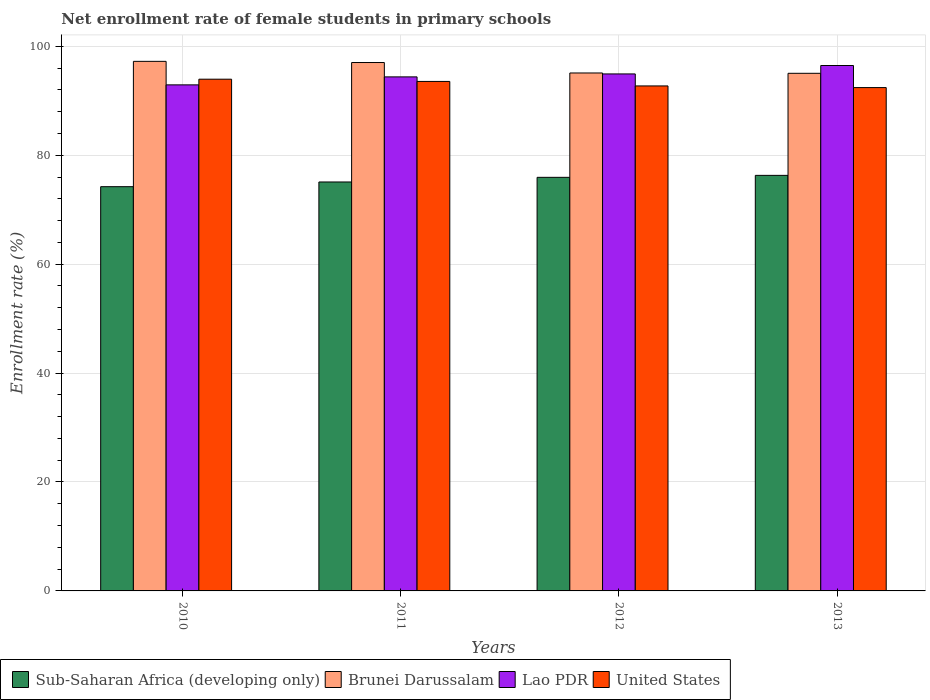What is the label of the 4th group of bars from the left?
Your response must be concise. 2013. In how many cases, is the number of bars for a given year not equal to the number of legend labels?
Keep it short and to the point. 0. What is the net enrollment rate of female students in primary schools in United States in 2011?
Provide a succinct answer. 93.55. Across all years, what is the maximum net enrollment rate of female students in primary schools in United States?
Your answer should be compact. 93.96. Across all years, what is the minimum net enrollment rate of female students in primary schools in Brunei Darussalam?
Provide a succinct answer. 95.04. In which year was the net enrollment rate of female students in primary schools in United States maximum?
Offer a very short reply. 2010. In which year was the net enrollment rate of female students in primary schools in United States minimum?
Offer a terse response. 2013. What is the total net enrollment rate of female students in primary schools in Brunei Darussalam in the graph?
Your answer should be compact. 384.4. What is the difference between the net enrollment rate of female students in primary schools in Lao PDR in 2011 and that in 2012?
Make the answer very short. -0.54. What is the difference between the net enrollment rate of female students in primary schools in Lao PDR in 2010 and the net enrollment rate of female students in primary schools in Brunei Darussalam in 2013?
Your answer should be compact. -2.12. What is the average net enrollment rate of female students in primary schools in Lao PDR per year?
Your answer should be very brief. 94.68. In the year 2012, what is the difference between the net enrollment rate of female students in primary schools in Sub-Saharan Africa (developing only) and net enrollment rate of female students in primary schools in United States?
Your answer should be compact. -16.78. What is the ratio of the net enrollment rate of female students in primary schools in United States in 2010 to that in 2013?
Your response must be concise. 1.02. What is the difference between the highest and the second highest net enrollment rate of female students in primary schools in Brunei Darussalam?
Ensure brevity in your answer.  0.21. What is the difference between the highest and the lowest net enrollment rate of female students in primary schools in Lao PDR?
Offer a very short reply. 3.55. Is the sum of the net enrollment rate of female students in primary schools in Brunei Darussalam in 2012 and 2013 greater than the maximum net enrollment rate of female students in primary schools in Sub-Saharan Africa (developing only) across all years?
Make the answer very short. Yes. Is it the case that in every year, the sum of the net enrollment rate of female students in primary schools in Brunei Darussalam and net enrollment rate of female students in primary schools in Lao PDR is greater than the sum of net enrollment rate of female students in primary schools in Sub-Saharan Africa (developing only) and net enrollment rate of female students in primary schools in United States?
Provide a succinct answer. Yes. What does the 2nd bar from the left in 2012 represents?
Offer a terse response. Brunei Darussalam. What does the 2nd bar from the right in 2013 represents?
Your response must be concise. Lao PDR. Does the graph contain grids?
Your response must be concise. Yes. How many legend labels are there?
Your response must be concise. 4. How are the legend labels stacked?
Provide a succinct answer. Horizontal. What is the title of the graph?
Provide a succinct answer. Net enrollment rate of female students in primary schools. What is the label or title of the X-axis?
Make the answer very short. Years. What is the label or title of the Y-axis?
Keep it short and to the point. Enrollment rate (%). What is the Enrollment rate (%) in Sub-Saharan Africa (developing only) in 2010?
Make the answer very short. 74.22. What is the Enrollment rate (%) of Brunei Darussalam in 2010?
Your answer should be very brief. 97.24. What is the Enrollment rate (%) in Lao PDR in 2010?
Your response must be concise. 92.92. What is the Enrollment rate (%) of United States in 2010?
Your response must be concise. 93.96. What is the Enrollment rate (%) in Sub-Saharan Africa (developing only) in 2011?
Provide a succinct answer. 75.09. What is the Enrollment rate (%) in Brunei Darussalam in 2011?
Your answer should be compact. 97.02. What is the Enrollment rate (%) of Lao PDR in 2011?
Ensure brevity in your answer.  94.38. What is the Enrollment rate (%) in United States in 2011?
Provide a succinct answer. 93.55. What is the Enrollment rate (%) of Sub-Saharan Africa (developing only) in 2012?
Give a very brief answer. 75.94. What is the Enrollment rate (%) in Brunei Darussalam in 2012?
Offer a terse response. 95.1. What is the Enrollment rate (%) of Lao PDR in 2012?
Your response must be concise. 94.93. What is the Enrollment rate (%) in United States in 2012?
Keep it short and to the point. 92.72. What is the Enrollment rate (%) of Sub-Saharan Africa (developing only) in 2013?
Provide a short and direct response. 76.3. What is the Enrollment rate (%) of Brunei Darussalam in 2013?
Your answer should be very brief. 95.04. What is the Enrollment rate (%) in Lao PDR in 2013?
Offer a very short reply. 96.47. What is the Enrollment rate (%) in United States in 2013?
Give a very brief answer. 92.42. Across all years, what is the maximum Enrollment rate (%) of Sub-Saharan Africa (developing only)?
Offer a terse response. 76.3. Across all years, what is the maximum Enrollment rate (%) of Brunei Darussalam?
Keep it short and to the point. 97.24. Across all years, what is the maximum Enrollment rate (%) in Lao PDR?
Ensure brevity in your answer.  96.47. Across all years, what is the maximum Enrollment rate (%) of United States?
Make the answer very short. 93.96. Across all years, what is the minimum Enrollment rate (%) in Sub-Saharan Africa (developing only)?
Keep it short and to the point. 74.22. Across all years, what is the minimum Enrollment rate (%) in Brunei Darussalam?
Your response must be concise. 95.04. Across all years, what is the minimum Enrollment rate (%) in Lao PDR?
Your answer should be compact. 92.92. Across all years, what is the minimum Enrollment rate (%) in United States?
Make the answer very short. 92.42. What is the total Enrollment rate (%) in Sub-Saharan Africa (developing only) in the graph?
Provide a succinct answer. 301.55. What is the total Enrollment rate (%) in Brunei Darussalam in the graph?
Provide a succinct answer. 384.4. What is the total Enrollment rate (%) of Lao PDR in the graph?
Make the answer very short. 378.7. What is the total Enrollment rate (%) of United States in the graph?
Give a very brief answer. 372.65. What is the difference between the Enrollment rate (%) in Sub-Saharan Africa (developing only) in 2010 and that in 2011?
Make the answer very short. -0.86. What is the difference between the Enrollment rate (%) in Brunei Darussalam in 2010 and that in 2011?
Provide a short and direct response. 0.21. What is the difference between the Enrollment rate (%) in Lao PDR in 2010 and that in 2011?
Keep it short and to the point. -1.46. What is the difference between the Enrollment rate (%) in United States in 2010 and that in 2011?
Make the answer very short. 0.41. What is the difference between the Enrollment rate (%) of Sub-Saharan Africa (developing only) in 2010 and that in 2012?
Your answer should be very brief. -1.71. What is the difference between the Enrollment rate (%) of Brunei Darussalam in 2010 and that in 2012?
Provide a short and direct response. 2.13. What is the difference between the Enrollment rate (%) in Lao PDR in 2010 and that in 2012?
Your answer should be compact. -2.01. What is the difference between the Enrollment rate (%) in United States in 2010 and that in 2012?
Ensure brevity in your answer.  1.24. What is the difference between the Enrollment rate (%) in Sub-Saharan Africa (developing only) in 2010 and that in 2013?
Your answer should be very brief. -2.08. What is the difference between the Enrollment rate (%) of Brunei Darussalam in 2010 and that in 2013?
Offer a terse response. 2.19. What is the difference between the Enrollment rate (%) in Lao PDR in 2010 and that in 2013?
Offer a very short reply. -3.55. What is the difference between the Enrollment rate (%) in United States in 2010 and that in 2013?
Offer a very short reply. 1.54. What is the difference between the Enrollment rate (%) in Sub-Saharan Africa (developing only) in 2011 and that in 2012?
Your answer should be very brief. -0.85. What is the difference between the Enrollment rate (%) of Brunei Darussalam in 2011 and that in 2012?
Your response must be concise. 1.92. What is the difference between the Enrollment rate (%) in Lao PDR in 2011 and that in 2012?
Your response must be concise. -0.54. What is the difference between the Enrollment rate (%) of United States in 2011 and that in 2012?
Keep it short and to the point. 0.83. What is the difference between the Enrollment rate (%) in Sub-Saharan Africa (developing only) in 2011 and that in 2013?
Provide a short and direct response. -1.21. What is the difference between the Enrollment rate (%) of Brunei Darussalam in 2011 and that in 2013?
Offer a terse response. 1.98. What is the difference between the Enrollment rate (%) in Lao PDR in 2011 and that in 2013?
Ensure brevity in your answer.  -2.09. What is the difference between the Enrollment rate (%) of United States in 2011 and that in 2013?
Offer a very short reply. 1.13. What is the difference between the Enrollment rate (%) in Sub-Saharan Africa (developing only) in 2012 and that in 2013?
Offer a terse response. -0.36. What is the difference between the Enrollment rate (%) of Brunei Darussalam in 2012 and that in 2013?
Provide a short and direct response. 0.06. What is the difference between the Enrollment rate (%) in Lao PDR in 2012 and that in 2013?
Provide a succinct answer. -1.55. What is the difference between the Enrollment rate (%) in United States in 2012 and that in 2013?
Make the answer very short. 0.3. What is the difference between the Enrollment rate (%) of Sub-Saharan Africa (developing only) in 2010 and the Enrollment rate (%) of Brunei Darussalam in 2011?
Offer a terse response. -22.8. What is the difference between the Enrollment rate (%) of Sub-Saharan Africa (developing only) in 2010 and the Enrollment rate (%) of Lao PDR in 2011?
Offer a terse response. -20.16. What is the difference between the Enrollment rate (%) of Sub-Saharan Africa (developing only) in 2010 and the Enrollment rate (%) of United States in 2011?
Your response must be concise. -19.33. What is the difference between the Enrollment rate (%) in Brunei Darussalam in 2010 and the Enrollment rate (%) in Lao PDR in 2011?
Keep it short and to the point. 2.85. What is the difference between the Enrollment rate (%) in Brunei Darussalam in 2010 and the Enrollment rate (%) in United States in 2011?
Your answer should be compact. 3.69. What is the difference between the Enrollment rate (%) of Lao PDR in 2010 and the Enrollment rate (%) of United States in 2011?
Provide a short and direct response. -0.63. What is the difference between the Enrollment rate (%) in Sub-Saharan Africa (developing only) in 2010 and the Enrollment rate (%) in Brunei Darussalam in 2012?
Provide a short and direct response. -20.88. What is the difference between the Enrollment rate (%) in Sub-Saharan Africa (developing only) in 2010 and the Enrollment rate (%) in Lao PDR in 2012?
Offer a terse response. -20.7. What is the difference between the Enrollment rate (%) in Sub-Saharan Africa (developing only) in 2010 and the Enrollment rate (%) in United States in 2012?
Make the answer very short. -18.5. What is the difference between the Enrollment rate (%) of Brunei Darussalam in 2010 and the Enrollment rate (%) of Lao PDR in 2012?
Provide a succinct answer. 2.31. What is the difference between the Enrollment rate (%) in Brunei Darussalam in 2010 and the Enrollment rate (%) in United States in 2012?
Your response must be concise. 4.51. What is the difference between the Enrollment rate (%) in Lao PDR in 2010 and the Enrollment rate (%) in United States in 2012?
Your answer should be compact. 0.2. What is the difference between the Enrollment rate (%) in Sub-Saharan Africa (developing only) in 2010 and the Enrollment rate (%) in Brunei Darussalam in 2013?
Offer a very short reply. -20.82. What is the difference between the Enrollment rate (%) in Sub-Saharan Africa (developing only) in 2010 and the Enrollment rate (%) in Lao PDR in 2013?
Offer a very short reply. -22.25. What is the difference between the Enrollment rate (%) in Sub-Saharan Africa (developing only) in 2010 and the Enrollment rate (%) in United States in 2013?
Your answer should be compact. -18.2. What is the difference between the Enrollment rate (%) of Brunei Darussalam in 2010 and the Enrollment rate (%) of Lao PDR in 2013?
Make the answer very short. 0.76. What is the difference between the Enrollment rate (%) of Brunei Darussalam in 2010 and the Enrollment rate (%) of United States in 2013?
Your answer should be very brief. 4.82. What is the difference between the Enrollment rate (%) of Lao PDR in 2010 and the Enrollment rate (%) of United States in 2013?
Give a very brief answer. 0.5. What is the difference between the Enrollment rate (%) of Sub-Saharan Africa (developing only) in 2011 and the Enrollment rate (%) of Brunei Darussalam in 2012?
Provide a succinct answer. -20.01. What is the difference between the Enrollment rate (%) of Sub-Saharan Africa (developing only) in 2011 and the Enrollment rate (%) of Lao PDR in 2012?
Keep it short and to the point. -19.84. What is the difference between the Enrollment rate (%) in Sub-Saharan Africa (developing only) in 2011 and the Enrollment rate (%) in United States in 2012?
Keep it short and to the point. -17.64. What is the difference between the Enrollment rate (%) of Brunei Darussalam in 2011 and the Enrollment rate (%) of Lao PDR in 2012?
Provide a succinct answer. 2.09. What is the difference between the Enrollment rate (%) in Brunei Darussalam in 2011 and the Enrollment rate (%) in United States in 2012?
Offer a terse response. 4.3. What is the difference between the Enrollment rate (%) of Lao PDR in 2011 and the Enrollment rate (%) of United States in 2012?
Your answer should be very brief. 1.66. What is the difference between the Enrollment rate (%) in Sub-Saharan Africa (developing only) in 2011 and the Enrollment rate (%) in Brunei Darussalam in 2013?
Make the answer very short. -19.95. What is the difference between the Enrollment rate (%) in Sub-Saharan Africa (developing only) in 2011 and the Enrollment rate (%) in Lao PDR in 2013?
Offer a terse response. -21.39. What is the difference between the Enrollment rate (%) of Sub-Saharan Africa (developing only) in 2011 and the Enrollment rate (%) of United States in 2013?
Provide a succinct answer. -17.33. What is the difference between the Enrollment rate (%) of Brunei Darussalam in 2011 and the Enrollment rate (%) of Lao PDR in 2013?
Provide a succinct answer. 0.55. What is the difference between the Enrollment rate (%) in Brunei Darussalam in 2011 and the Enrollment rate (%) in United States in 2013?
Your response must be concise. 4.6. What is the difference between the Enrollment rate (%) of Lao PDR in 2011 and the Enrollment rate (%) of United States in 2013?
Offer a terse response. 1.96. What is the difference between the Enrollment rate (%) of Sub-Saharan Africa (developing only) in 2012 and the Enrollment rate (%) of Brunei Darussalam in 2013?
Make the answer very short. -19.1. What is the difference between the Enrollment rate (%) of Sub-Saharan Africa (developing only) in 2012 and the Enrollment rate (%) of Lao PDR in 2013?
Provide a short and direct response. -20.54. What is the difference between the Enrollment rate (%) of Sub-Saharan Africa (developing only) in 2012 and the Enrollment rate (%) of United States in 2013?
Offer a very short reply. -16.48. What is the difference between the Enrollment rate (%) in Brunei Darussalam in 2012 and the Enrollment rate (%) in Lao PDR in 2013?
Provide a succinct answer. -1.37. What is the difference between the Enrollment rate (%) of Brunei Darussalam in 2012 and the Enrollment rate (%) of United States in 2013?
Keep it short and to the point. 2.68. What is the difference between the Enrollment rate (%) in Lao PDR in 2012 and the Enrollment rate (%) in United States in 2013?
Ensure brevity in your answer.  2.51. What is the average Enrollment rate (%) of Sub-Saharan Africa (developing only) per year?
Your answer should be very brief. 75.39. What is the average Enrollment rate (%) in Brunei Darussalam per year?
Ensure brevity in your answer.  96.1. What is the average Enrollment rate (%) of Lao PDR per year?
Provide a short and direct response. 94.68. What is the average Enrollment rate (%) of United States per year?
Offer a very short reply. 93.16. In the year 2010, what is the difference between the Enrollment rate (%) of Sub-Saharan Africa (developing only) and Enrollment rate (%) of Brunei Darussalam?
Ensure brevity in your answer.  -23.01. In the year 2010, what is the difference between the Enrollment rate (%) of Sub-Saharan Africa (developing only) and Enrollment rate (%) of Lao PDR?
Give a very brief answer. -18.69. In the year 2010, what is the difference between the Enrollment rate (%) in Sub-Saharan Africa (developing only) and Enrollment rate (%) in United States?
Your answer should be compact. -19.73. In the year 2010, what is the difference between the Enrollment rate (%) in Brunei Darussalam and Enrollment rate (%) in Lao PDR?
Ensure brevity in your answer.  4.32. In the year 2010, what is the difference between the Enrollment rate (%) of Brunei Darussalam and Enrollment rate (%) of United States?
Make the answer very short. 3.28. In the year 2010, what is the difference between the Enrollment rate (%) in Lao PDR and Enrollment rate (%) in United States?
Make the answer very short. -1.04. In the year 2011, what is the difference between the Enrollment rate (%) of Sub-Saharan Africa (developing only) and Enrollment rate (%) of Brunei Darussalam?
Keep it short and to the point. -21.93. In the year 2011, what is the difference between the Enrollment rate (%) in Sub-Saharan Africa (developing only) and Enrollment rate (%) in Lao PDR?
Provide a short and direct response. -19.3. In the year 2011, what is the difference between the Enrollment rate (%) of Sub-Saharan Africa (developing only) and Enrollment rate (%) of United States?
Make the answer very short. -18.46. In the year 2011, what is the difference between the Enrollment rate (%) in Brunei Darussalam and Enrollment rate (%) in Lao PDR?
Your answer should be compact. 2.64. In the year 2011, what is the difference between the Enrollment rate (%) of Brunei Darussalam and Enrollment rate (%) of United States?
Ensure brevity in your answer.  3.47. In the year 2011, what is the difference between the Enrollment rate (%) of Lao PDR and Enrollment rate (%) of United States?
Keep it short and to the point. 0.83. In the year 2012, what is the difference between the Enrollment rate (%) of Sub-Saharan Africa (developing only) and Enrollment rate (%) of Brunei Darussalam?
Ensure brevity in your answer.  -19.16. In the year 2012, what is the difference between the Enrollment rate (%) of Sub-Saharan Africa (developing only) and Enrollment rate (%) of Lao PDR?
Give a very brief answer. -18.99. In the year 2012, what is the difference between the Enrollment rate (%) in Sub-Saharan Africa (developing only) and Enrollment rate (%) in United States?
Ensure brevity in your answer.  -16.78. In the year 2012, what is the difference between the Enrollment rate (%) in Brunei Darussalam and Enrollment rate (%) in Lao PDR?
Provide a succinct answer. 0.17. In the year 2012, what is the difference between the Enrollment rate (%) of Brunei Darussalam and Enrollment rate (%) of United States?
Make the answer very short. 2.38. In the year 2012, what is the difference between the Enrollment rate (%) of Lao PDR and Enrollment rate (%) of United States?
Your answer should be very brief. 2.2. In the year 2013, what is the difference between the Enrollment rate (%) in Sub-Saharan Africa (developing only) and Enrollment rate (%) in Brunei Darussalam?
Your answer should be compact. -18.74. In the year 2013, what is the difference between the Enrollment rate (%) in Sub-Saharan Africa (developing only) and Enrollment rate (%) in Lao PDR?
Make the answer very short. -20.17. In the year 2013, what is the difference between the Enrollment rate (%) of Sub-Saharan Africa (developing only) and Enrollment rate (%) of United States?
Your answer should be compact. -16.12. In the year 2013, what is the difference between the Enrollment rate (%) of Brunei Darussalam and Enrollment rate (%) of Lao PDR?
Offer a very short reply. -1.43. In the year 2013, what is the difference between the Enrollment rate (%) in Brunei Darussalam and Enrollment rate (%) in United States?
Provide a short and direct response. 2.62. In the year 2013, what is the difference between the Enrollment rate (%) of Lao PDR and Enrollment rate (%) of United States?
Offer a terse response. 4.05. What is the ratio of the Enrollment rate (%) of Lao PDR in 2010 to that in 2011?
Keep it short and to the point. 0.98. What is the ratio of the Enrollment rate (%) of United States in 2010 to that in 2011?
Your response must be concise. 1. What is the ratio of the Enrollment rate (%) of Sub-Saharan Africa (developing only) in 2010 to that in 2012?
Provide a short and direct response. 0.98. What is the ratio of the Enrollment rate (%) in Brunei Darussalam in 2010 to that in 2012?
Offer a very short reply. 1.02. What is the ratio of the Enrollment rate (%) of Lao PDR in 2010 to that in 2012?
Offer a very short reply. 0.98. What is the ratio of the Enrollment rate (%) of United States in 2010 to that in 2012?
Your answer should be very brief. 1.01. What is the ratio of the Enrollment rate (%) in Sub-Saharan Africa (developing only) in 2010 to that in 2013?
Ensure brevity in your answer.  0.97. What is the ratio of the Enrollment rate (%) in Brunei Darussalam in 2010 to that in 2013?
Your answer should be compact. 1.02. What is the ratio of the Enrollment rate (%) in Lao PDR in 2010 to that in 2013?
Your response must be concise. 0.96. What is the ratio of the Enrollment rate (%) in United States in 2010 to that in 2013?
Your answer should be very brief. 1.02. What is the ratio of the Enrollment rate (%) of Sub-Saharan Africa (developing only) in 2011 to that in 2012?
Ensure brevity in your answer.  0.99. What is the ratio of the Enrollment rate (%) of Brunei Darussalam in 2011 to that in 2012?
Provide a short and direct response. 1.02. What is the ratio of the Enrollment rate (%) in United States in 2011 to that in 2012?
Keep it short and to the point. 1.01. What is the ratio of the Enrollment rate (%) of Sub-Saharan Africa (developing only) in 2011 to that in 2013?
Keep it short and to the point. 0.98. What is the ratio of the Enrollment rate (%) in Brunei Darussalam in 2011 to that in 2013?
Your answer should be compact. 1.02. What is the ratio of the Enrollment rate (%) in Lao PDR in 2011 to that in 2013?
Your answer should be very brief. 0.98. What is the ratio of the Enrollment rate (%) in United States in 2011 to that in 2013?
Provide a short and direct response. 1.01. What is the ratio of the Enrollment rate (%) of Sub-Saharan Africa (developing only) in 2012 to that in 2013?
Offer a very short reply. 1. What is the ratio of the Enrollment rate (%) of Brunei Darussalam in 2012 to that in 2013?
Your answer should be very brief. 1. What is the ratio of the Enrollment rate (%) in Lao PDR in 2012 to that in 2013?
Offer a very short reply. 0.98. What is the ratio of the Enrollment rate (%) of United States in 2012 to that in 2013?
Your answer should be compact. 1. What is the difference between the highest and the second highest Enrollment rate (%) in Sub-Saharan Africa (developing only)?
Your answer should be very brief. 0.36. What is the difference between the highest and the second highest Enrollment rate (%) of Brunei Darussalam?
Your response must be concise. 0.21. What is the difference between the highest and the second highest Enrollment rate (%) in Lao PDR?
Provide a succinct answer. 1.55. What is the difference between the highest and the second highest Enrollment rate (%) of United States?
Your answer should be very brief. 0.41. What is the difference between the highest and the lowest Enrollment rate (%) in Sub-Saharan Africa (developing only)?
Provide a short and direct response. 2.08. What is the difference between the highest and the lowest Enrollment rate (%) of Brunei Darussalam?
Offer a very short reply. 2.19. What is the difference between the highest and the lowest Enrollment rate (%) in Lao PDR?
Your answer should be compact. 3.55. What is the difference between the highest and the lowest Enrollment rate (%) of United States?
Make the answer very short. 1.54. 